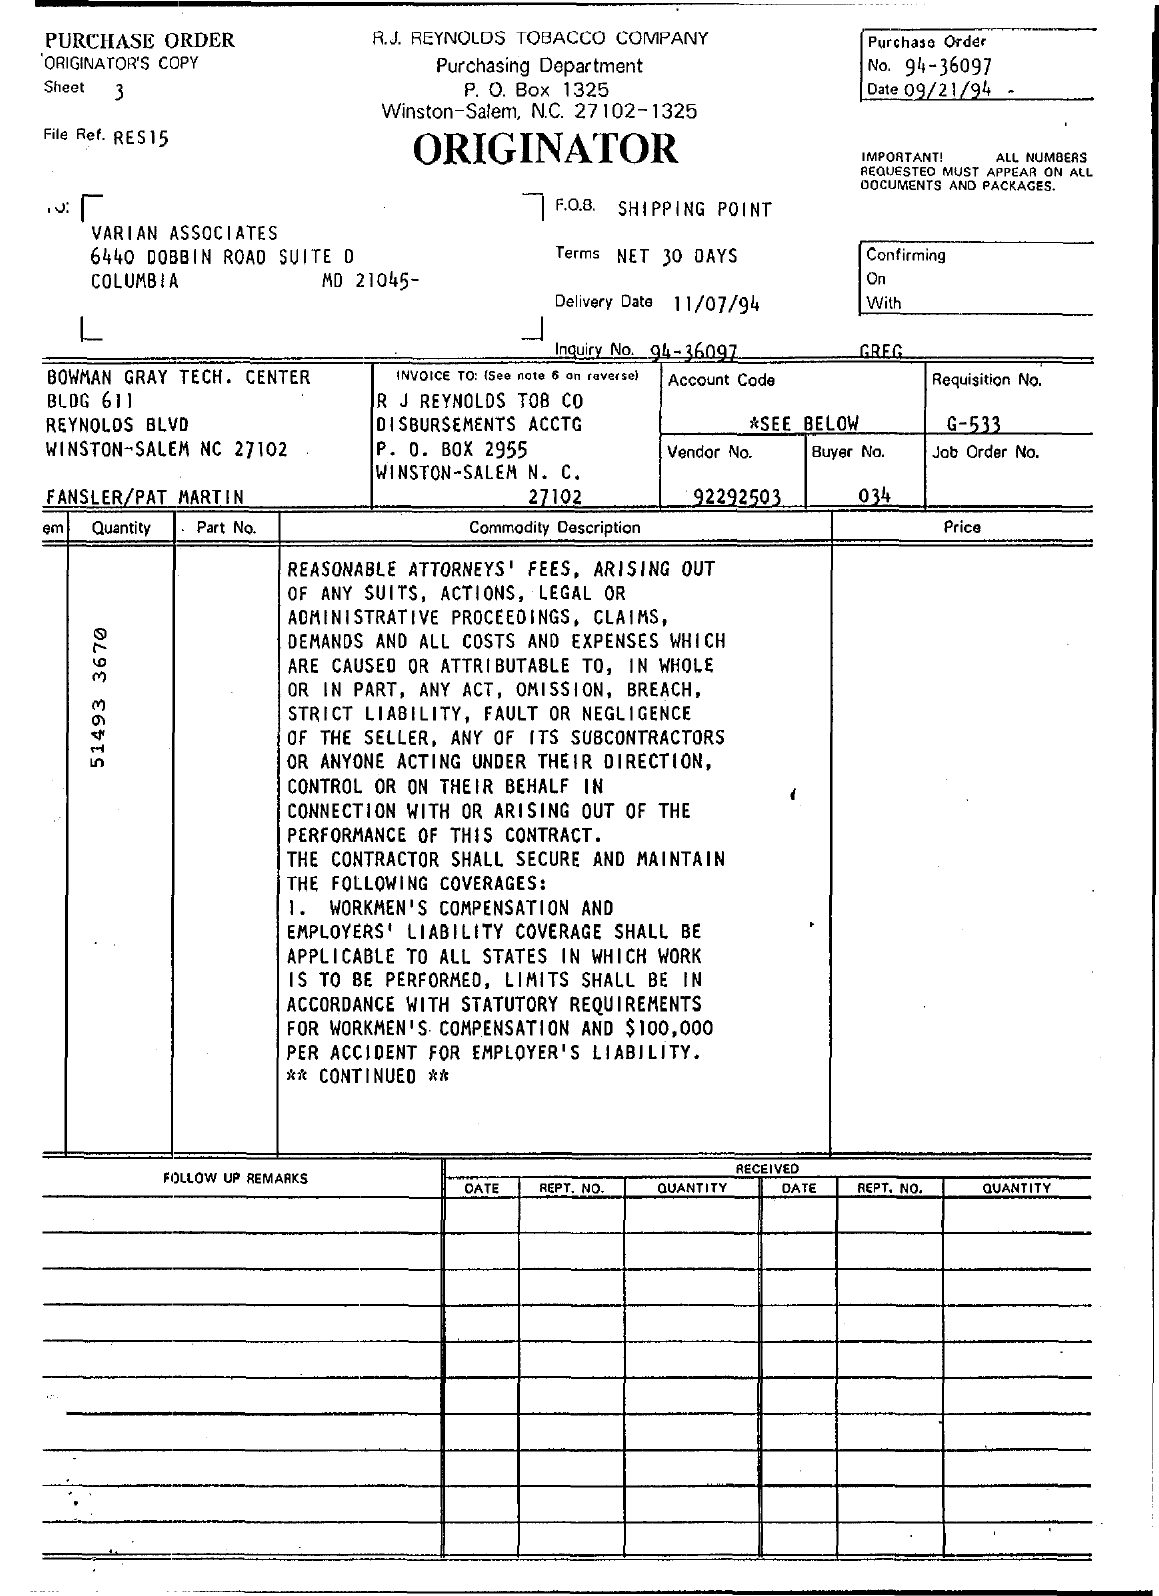Outline some significant characteristics in this image. The delivery date is 11/07/94. The Purchase Order Date is September 21, 1994. The requisition number is G-533.. The buyer number is 034. The vendor number is 92292503... 